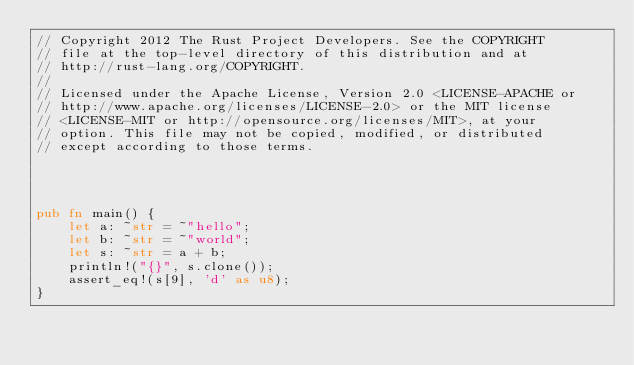Convert code to text. <code><loc_0><loc_0><loc_500><loc_500><_Rust_>// Copyright 2012 The Rust Project Developers. See the COPYRIGHT
// file at the top-level directory of this distribution and at
// http://rust-lang.org/COPYRIGHT.
//
// Licensed under the Apache License, Version 2.0 <LICENSE-APACHE or
// http://www.apache.org/licenses/LICENSE-2.0> or the MIT license
// <LICENSE-MIT or http://opensource.org/licenses/MIT>, at your
// option. This file may not be copied, modified, or distributed
// except according to those terms.




pub fn main() {
    let a: ~str = ~"hello";
    let b: ~str = ~"world";
    let s: ~str = a + b;
    println!("{}", s.clone());
    assert_eq!(s[9], 'd' as u8);
}
</code> 